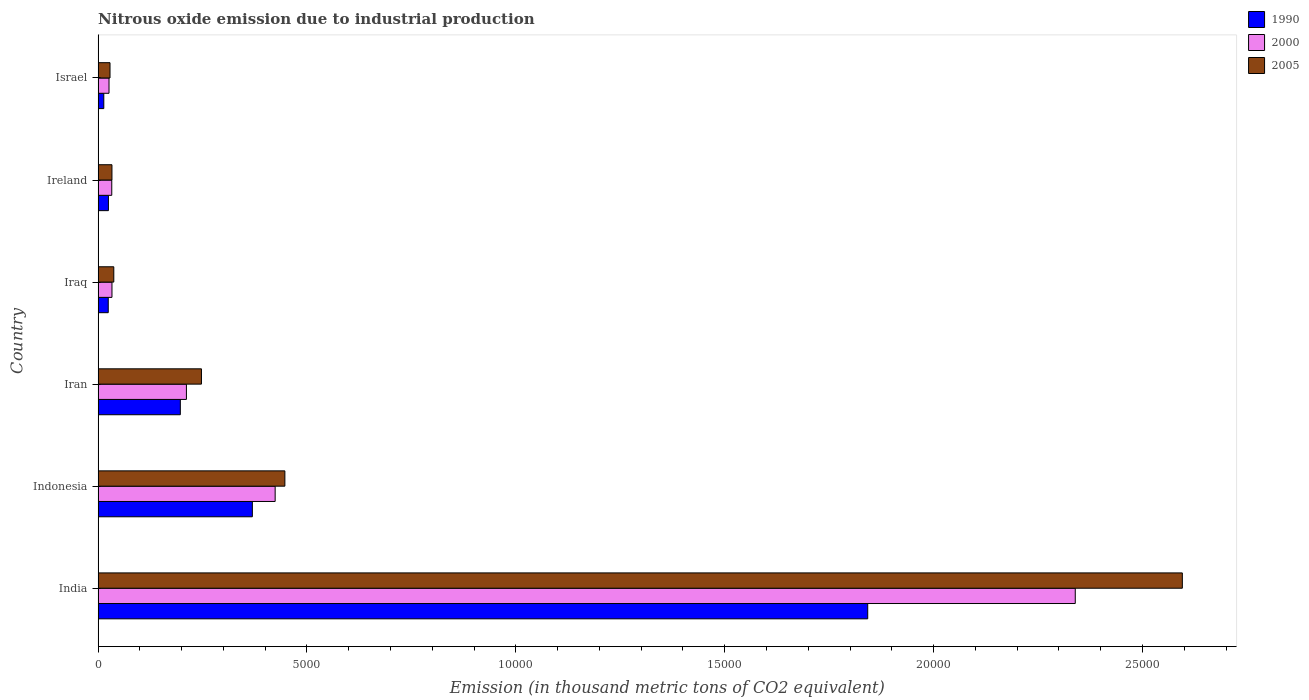How many bars are there on the 6th tick from the top?
Keep it short and to the point. 3. How many bars are there on the 4th tick from the bottom?
Your response must be concise. 3. What is the amount of nitrous oxide emitted in 2005 in Israel?
Your response must be concise. 284.9. Across all countries, what is the maximum amount of nitrous oxide emitted in 2005?
Make the answer very short. 2.60e+04. Across all countries, what is the minimum amount of nitrous oxide emitted in 2005?
Your answer should be very brief. 284.9. In which country was the amount of nitrous oxide emitted in 2000 maximum?
Provide a short and direct response. India. What is the total amount of nitrous oxide emitted in 1990 in the graph?
Make the answer very short. 2.47e+04. What is the difference between the amount of nitrous oxide emitted in 1990 in Indonesia and that in Israel?
Keep it short and to the point. 3556.6. What is the difference between the amount of nitrous oxide emitted in 2005 in Israel and the amount of nitrous oxide emitted in 1990 in Indonesia?
Make the answer very short. -3407.5. What is the average amount of nitrous oxide emitted in 1990 per country?
Offer a terse response. 4118.03. What is the difference between the amount of nitrous oxide emitted in 2005 and amount of nitrous oxide emitted in 1990 in Iraq?
Provide a succinct answer. 133.1. In how many countries, is the amount of nitrous oxide emitted in 2005 greater than 25000 thousand metric tons?
Offer a very short reply. 1. What is the ratio of the amount of nitrous oxide emitted in 2000 in India to that in Iran?
Ensure brevity in your answer.  11.07. What is the difference between the highest and the second highest amount of nitrous oxide emitted in 2000?
Your answer should be very brief. 1.92e+04. What is the difference between the highest and the lowest amount of nitrous oxide emitted in 2005?
Make the answer very short. 2.57e+04. What does the 3rd bar from the top in Ireland represents?
Offer a very short reply. 1990. Is it the case that in every country, the sum of the amount of nitrous oxide emitted in 1990 and amount of nitrous oxide emitted in 2005 is greater than the amount of nitrous oxide emitted in 2000?
Your answer should be very brief. Yes. How many bars are there?
Offer a terse response. 18. How many countries are there in the graph?
Give a very brief answer. 6. Are the values on the major ticks of X-axis written in scientific E-notation?
Your response must be concise. No. Does the graph contain any zero values?
Your answer should be compact. No. Does the graph contain grids?
Offer a terse response. No. Where does the legend appear in the graph?
Your response must be concise. Top right. How many legend labels are there?
Your answer should be very brief. 3. What is the title of the graph?
Your answer should be very brief. Nitrous oxide emission due to industrial production. What is the label or title of the X-axis?
Provide a short and direct response. Emission (in thousand metric tons of CO2 equivalent). What is the Emission (in thousand metric tons of CO2 equivalent) in 1990 in India?
Offer a terse response. 1.84e+04. What is the Emission (in thousand metric tons of CO2 equivalent) of 2000 in India?
Your answer should be very brief. 2.34e+04. What is the Emission (in thousand metric tons of CO2 equivalent) in 2005 in India?
Provide a short and direct response. 2.60e+04. What is the Emission (in thousand metric tons of CO2 equivalent) of 1990 in Indonesia?
Offer a very short reply. 3692.4. What is the Emission (in thousand metric tons of CO2 equivalent) in 2000 in Indonesia?
Your response must be concise. 4237.9. What is the Emission (in thousand metric tons of CO2 equivalent) of 2005 in Indonesia?
Your answer should be compact. 4470.7. What is the Emission (in thousand metric tons of CO2 equivalent) in 1990 in Iran?
Your answer should be very brief. 1968.1. What is the Emission (in thousand metric tons of CO2 equivalent) in 2000 in Iran?
Give a very brief answer. 2113.8. What is the Emission (in thousand metric tons of CO2 equivalent) in 2005 in Iran?
Offer a very short reply. 2473.5. What is the Emission (in thousand metric tons of CO2 equivalent) in 1990 in Iraq?
Keep it short and to the point. 242.4. What is the Emission (in thousand metric tons of CO2 equivalent) of 2000 in Iraq?
Provide a short and direct response. 331.4. What is the Emission (in thousand metric tons of CO2 equivalent) in 2005 in Iraq?
Ensure brevity in your answer.  375.5. What is the Emission (in thousand metric tons of CO2 equivalent) in 1990 in Ireland?
Offer a terse response. 246.7. What is the Emission (in thousand metric tons of CO2 equivalent) of 2000 in Ireland?
Offer a very short reply. 326.6. What is the Emission (in thousand metric tons of CO2 equivalent) of 2005 in Ireland?
Your response must be concise. 331.1. What is the Emission (in thousand metric tons of CO2 equivalent) of 1990 in Israel?
Your answer should be very brief. 135.8. What is the Emission (in thousand metric tons of CO2 equivalent) of 2000 in Israel?
Your answer should be compact. 260.8. What is the Emission (in thousand metric tons of CO2 equivalent) of 2005 in Israel?
Provide a short and direct response. 284.9. Across all countries, what is the maximum Emission (in thousand metric tons of CO2 equivalent) in 1990?
Provide a succinct answer. 1.84e+04. Across all countries, what is the maximum Emission (in thousand metric tons of CO2 equivalent) in 2000?
Offer a terse response. 2.34e+04. Across all countries, what is the maximum Emission (in thousand metric tons of CO2 equivalent) in 2005?
Ensure brevity in your answer.  2.60e+04. Across all countries, what is the minimum Emission (in thousand metric tons of CO2 equivalent) in 1990?
Your answer should be very brief. 135.8. Across all countries, what is the minimum Emission (in thousand metric tons of CO2 equivalent) of 2000?
Provide a succinct answer. 260.8. Across all countries, what is the minimum Emission (in thousand metric tons of CO2 equivalent) in 2005?
Ensure brevity in your answer.  284.9. What is the total Emission (in thousand metric tons of CO2 equivalent) of 1990 in the graph?
Make the answer very short. 2.47e+04. What is the total Emission (in thousand metric tons of CO2 equivalent) of 2000 in the graph?
Provide a short and direct response. 3.07e+04. What is the total Emission (in thousand metric tons of CO2 equivalent) of 2005 in the graph?
Keep it short and to the point. 3.39e+04. What is the difference between the Emission (in thousand metric tons of CO2 equivalent) of 1990 in India and that in Indonesia?
Your answer should be very brief. 1.47e+04. What is the difference between the Emission (in thousand metric tons of CO2 equivalent) of 2000 in India and that in Indonesia?
Ensure brevity in your answer.  1.92e+04. What is the difference between the Emission (in thousand metric tons of CO2 equivalent) of 2005 in India and that in Indonesia?
Offer a terse response. 2.15e+04. What is the difference between the Emission (in thousand metric tons of CO2 equivalent) of 1990 in India and that in Iran?
Offer a terse response. 1.65e+04. What is the difference between the Emission (in thousand metric tons of CO2 equivalent) in 2000 in India and that in Iran?
Make the answer very short. 2.13e+04. What is the difference between the Emission (in thousand metric tons of CO2 equivalent) of 2005 in India and that in Iran?
Make the answer very short. 2.35e+04. What is the difference between the Emission (in thousand metric tons of CO2 equivalent) of 1990 in India and that in Iraq?
Offer a very short reply. 1.82e+04. What is the difference between the Emission (in thousand metric tons of CO2 equivalent) of 2000 in India and that in Iraq?
Your answer should be compact. 2.31e+04. What is the difference between the Emission (in thousand metric tons of CO2 equivalent) of 2005 in India and that in Iraq?
Provide a succinct answer. 2.56e+04. What is the difference between the Emission (in thousand metric tons of CO2 equivalent) in 1990 in India and that in Ireland?
Keep it short and to the point. 1.82e+04. What is the difference between the Emission (in thousand metric tons of CO2 equivalent) of 2000 in India and that in Ireland?
Keep it short and to the point. 2.31e+04. What is the difference between the Emission (in thousand metric tons of CO2 equivalent) in 2005 in India and that in Ireland?
Your answer should be compact. 2.56e+04. What is the difference between the Emission (in thousand metric tons of CO2 equivalent) of 1990 in India and that in Israel?
Make the answer very short. 1.83e+04. What is the difference between the Emission (in thousand metric tons of CO2 equivalent) in 2000 in India and that in Israel?
Provide a short and direct response. 2.31e+04. What is the difference between the Emission (in thousand metric tons of CO2 equivalent) in 2005 in India and that in Israel?
Your answer should be very brief. 2.57e+04. What is the difference between the Emission (in thousand metric tons of CO2 equivalent) in 1990 in Indonesia and that in Iran?
Your answer should be compact. 1724.3. What is the difference between the Emission (in thousand metric tons of CO2 equivalent) in 2000 in Indonesia and that in Iran?
Give a very brief answer. 2124.1. What is the difference between the Emission (in thousand metric tons of CO2 equivalent) in 2005 in Indonesia and that in Iran?
Provide a succinct answer. 1997.2. What is the difference between the Emission (in thousand metric tons of CO2 equivalent) in 1990 in Indonesia and that in Iraq?
Offer a terse response. 3450. What is the difference between the Emission (in thousand metric tons of CO2 equivalent) in 2000 in Indonesia and that in Iraq?
Your response must be concise. 3906.5. What is the difference between the Emission (in thousand metric tons of CO2 equivalent) of 2005 in Indonesia and that in Iraq?
Your answer should be very brief. 4095.2. What is the difference between the Emission (in thousand metric tons of CO2 equivalent) of 1990 in Indonesia and that in Ireland?
Your response must be concise. 3445.7. What is the difference between the Emission (in thousand metric tons of CO2 equivalent) in 2000 in Indonesia and that in Ireland?
Offer a terse response. 3911.3. What is the difference between the Emission (in thousand metric tons of CO2 equivalent) in 2005 in Indonesia and that in Ireland?
Your answer should be compact. 4139.6. What is the difference between the Emission (in thousand metric tons of CO2 equivalent) in 1990 in Indonesia and that in Israel?
Your answer should be very brief. 3556.6. What is the difference between the Emission (in thousand metric tons of CO2 equivalent) of 2000 in Indonesia and that in Israel?
Your answer should be compact. 3977.1. What is the difference between the Emission (in thousand metric tons of CO2 equivalent) in 2005 in Indonesia and that in Israel?
Keep it short and to the point. 4185.8. What is the difference between the Emission (in thousand metric tons of CO2 equivalent) in 1990 in Iran and that in Iraq?
Offer a very short reply. 1725.7. What is the difference between the Emission (in thousand metric tons of CO2 equivalent) in 2000 in Iran and that in Iraq?
Offer a very short reply. 1782.4. What is the difference between the Emission (in thousand metric tons of CO2 equivalent) in 2005 in Iran and that in Iraq?
Provide a succinct answer. 2098. What is the difference between the Emission (in thousand metric tons of CO2 equivalent) in 1990 in Iran and that in Ireland?
Provide a succinct answer. 1721.4. What is the difference between the Emission (in thousand metric tons of CO2 equivalent) in 2000 in Iran and that in Ireland?
Provide a short and direct response. 1787.2. What is the difference between the Emission (in thousand metric tons of CO2 equivalent) in 2005 in Iran and that in Ireland?
Ensure brevity in your answer.  2142.4. What is the difference between the Emission (in thousand metric tons of CO2 equivalent) in 1990 in Iran and that in Israel?
Provide a short and direct response. 1832.3. What is the difference between the Emission (in thousand metric tons of CO2 equivalent) of 2000 in Iran and that in Israel?
Offer a very short reply. 1853. What is the difference between the Emission (in thousand metric tons of CO2 equivalent) in 2005 in Iran and that in Israel?
Your response must be concise. 2188.6. What is the difference between the Emission (in thousand metric tons of CO2 equivalent) of 1990 in Iraq and that in Ireland?
Ensure brevity in your answer.  -4.3. What is the difference between the Emission (in thousand metric tons of CO2 equivalent) of 2005 in Iraq and that in Ireland?
Your answer should be compact. 44.4. What is the difference between the Emission (in thousand metric tons of CO2 equivalent) in 1990 in Iraq and that in Israel?
Your answer should be very brief. 106.6. What is the difference between the Emission (in thousand metric tons of CO2 equivalent) of 2000 in Iraq and that in Israel?
Your answer should be very brief. 70.6. What is the difference between the Emission (in thousand metric tons of CO2 equivalent) of 2005 in Iraq and that in Israel?
Make the answer very short. 90.6. What is the difference between the Emission (in thousand metric tons of CO2 equivalent) in 1990 in Ireland and that in Israel?
Make the answer very short. 110.9. What is the difference between the Emission (in thousand metric tons of CO2 equivalent) of 2000 in Ireland and that in Israel?
Offer a terse response. 65.8. What is the difference between the Emission (in thousand metric tons of CO2 equivalent) in 2005 in Ireland and that in Israel?
Offer a terse response. 46.2. What is the difference between the Emission (in thousand metric tons of CO2 equivalent) in 1990 in India and the Emission (in thousand metric tons of CO2 equivalent) in 2000 in Indonesia?
Give a very brief answer. 1.42e+04. What is the difference between the Emission (in thousand metric tons of CO2 equivalent) of 1990 in India and the Emission (in thousand metric tons of CO2 equivalent) of 2005 in Indonesia?
Provide a succinct answer. 1.40e+04. What is the difference between the Emission (in thousand metric tons of CO2 equivalent) of 2000 in India and the Emission (in thousand metric tons of CO2 equivalent) of 2005 in Indonesia?
Your answer should be very brief. 1.89e+04. What is the difference between the Emission (in thousand metric tons of CO2 equivalent) in 1990 in India and the Emission (in thousand metric tons of CO2 equivalent) in 2000 in Iran?
Provide a succinct answer. 1.63e+04. What is the difference between the Emission (in thousand metric tons of CO2 equivalent) of 1990 in India and the Emission (in thousand metric tons of CO2 equivalent) of 2005 in Iran?
Keep it short and to the point. 1.59e+04. What is the difference between the Emission (in thousand metric tons of CO2 equivalent) of 2000 in India and the Emission (in thousand metric tons of CO2 equivalent) of 2005 in Iran?
Ensure brevity in your answer.  2.09e+04. What is the difference between the Emission (in thousand metric tons of CO2 equivalent) in 1990 in India and the Emission (in thousand metric tons of CO2 equivalent) in 2000 in Iraq?
Your answer should be compact. 1.81e+04. What is the difference between the Emission (in thousand metric tons of CO2 equivalent) of 1990 in India and the Emission (in thousand metric tons of CO2 equivalent) of 2005 in Iraq?
Provide a short and direct response. 1.80e+04. What is the difference between the Emission (in thousand metric tons of CO2 equivalent) in 2000 in India and the Emission (in thousand metric tons of CO2 equivalent) in 2005 in Iraq?
Provide a succinct answer. 2.30e+04. What is the difference between the Emission (in thousand metric tons of CO2 equivalent) of 1990 in India and the Emission (in thousand metric tons of CO2 equivalent) of 2000 in Ireland?
Give a very brief answer. 1.81e+04. What is the difference between the Emission (in thousand metric tons of CO2 equivalent) in 1990 in India and the Emission (in thousand metric tons of CO2 equivalent) in 2005 in Ireland?
Make the answer very short. 1.81e+04. What is the difference between the Emission (in thousand metric tons of CO2 equivalent) in 2000 in India and the Emission (in thousand metric tons of CO2 equivalent) in 2005 in Ireland?
Provide a succinct answer. 2.31e+04. What is the difference between the Emission (in thousand metric tons of CO2 equivalent) in 1990 in India and the Emission (in thousand metric tons of CO2 equivalent) in 2000 in Israel?
Give a very brief answer. 1.82e+04. What is the difference between the Emission (in thousand metric tons of CO2 equivalent) in 1990 in India and the Emission (in thousand metric tons of CO2 equivalent) in 2005 in Israel?
Keep it short and to the point. 1.81e+04. What is the difference between the Emission (in thousand metric tons of CO2 equivalent) of 2000 in India and the Emission (in thousand metric tons of CO2 equivalent) of 2005 in Israel?
Your answer should be compact. 2.31e+04. What is the difference between the Emission (in thousand metric tons of CO2 equivalent) in 1990 in Indonesia and the Emission (in thousand metric tons of CO2 equivalent) in 2000 in Iran?
Your answer should be very brief. 1578.6. What is the difference between the Emission (in thousand metric tons of CO2 equivalent) in 1990 in Indonesia and the Emission (in thousand metric tons of CO2 equivalent) in 2005 in Iran?
Offer a very short reply. 1218.9. What is the difference between the Emission (in thousand metric tons of CO2 equivalent) of 2000 in Indonesia and the Emission (in thousand metric tons of CO2 equivalent) of 2005 in Iran?
Keep it short and to the point. 1764.4. What is the difference between the Emission (in thousand metric tons of CO2 equivalent) of 1990 in Indonesia and the Emission (in thousand metric tons of CO2 equivalent) of 2000 in Iraq?
Offer a terse response. 3361. What is the difference between the Emission (in thousand metric tons of CO2 equivalent) of 1990 in Indonesia and the Emission (in thousand metric tons of CO2 equivalent) of 2005 in Iraq?
Make the answer very short. 3316.9. What is the difference between the Emission (in thousand metric tons of CO2 equivalent) in 2000 in Indonesia and the Emission (in thousand metric tons of CO2 equivalent) in 2005 in Iraq?
Your answer should be very brief. 3862.4. What is the difference between the Emission (in thousand metric tons of CO2 equivalent) in 1990 in Indonesia and the Emission (in thousand metric tons of CO2 equivalent) in 2000 in Ireland?
Keep it short and to the point. 3365.8. What is the difference between the Emission (in thousand metric tons of CO2 equivalent) of 1990 in Indonesia and the Emission (in thousand metric tons of CO2 equivalent) of 2005 in Ireland?
Offer a terse response. 3361.3. What is the difference between the Emission (in thousand metric tons of CO2 equivalent) of 2000 in Indonesia and the Emission (in thousand metric tons of CO2 equivalent) of 2005 in Ireland?
Your answer should be compact. 3906.8. What is the difference between the Emission (in thousand metric tons of CO2 equivalent) in 1990 in Indonesia and the Emission (in thousand metric tons of CO2 equivalent) in 2000 in Israel?
Give a very brief answer. 3431.6. What is the difference between the Emission (in thousand metric tons of CO2 equivalent) in 1990 in Indonesia and the Emission (in thousand metric tons of CO2 equivalent) in 2005 in Israel?
Offer a very short reply. 3407.5. What is the difference between the Emission (in thousand metric tons of CO2 equivalent) of 2000 in Indonesia and the Emission (in thousand metric tons of CO2 equivalent) of 2005 in Israel?
Your answer should be very brief. 3953. What is the difference between the Emission (in thousand metric tons of CO2 equivalent) of 1990 in Iran and the Emission (in thousand metric tons of CO2 equivalent) of 2000 in Iraq?
Your answer should be very brief. 1636.7. What is the difference between the Emission (in thousand metric tons of CO2 equivalent) in 1990 in Iran and the Emission (in thousand metric tons of CO2 equivalent) in 2005 in Iraq?
Provide a succinct answer. 1592.6. What is the difference between the Emission (in thousand metric tons of CO2 equivalent) in 2000 in Iran and the Emission (in thousand metric tons of CO2 equivalent) in 2005 in Iraq?
Make the answer very short. 1738.3. What is the difference between the Emission (in thousand metric tons of CO2 equivalent) in 1990 in Iran and the Emission (in thousand metric tons of CO2 equivalent) in 2000 in Ireland?
Your answer should be very brief. 1641.5. What is the difference between the Emission (in thousand metric tons of CO2 equivalent) of 1990 in Iran and the Emission (in thousand metric tons of CO2 equivalent) of 2005 in Ireland?
Your answer should be very brief. 1637. What is the difference between the Emission (in thousand metric tons of CO2 equivalent) in 2000 in Iran and the Emission (in thousand metric tons of CO2 equivalent) in 2005 in Ireland?
Ensure brevity in your answer.  1782.7. What is the difference between the Emission (in thousand metric tons of CO2 equivalent) in 1990 in Iran and the Emission (in thousand metric tons of CO2 equivalent) in 2000 in Israel?
Make the answer very short. 1707.3. What is the difference between the Emission (in thousand metric tons of CO2 equivalent) in 1990 in Iran and the Emission (in thousand metric tons of CO2 equivalent) in 2005 in Israel?
Provide a short and direct response. 1683.2. What is the difference between the Emission (in thousand metric tons of CO2 equivalent) in 2000 in Iran and the Emission (in thousand metric tons of CO2 equivalent) in 2005 in Israel?
Keep it short and to the point. 1828.9. What is the difference between the Emission (in thousand metric tons of CO2 equivalent) of 1990 in Iraq and the Emission (in thousand metric tons of CO2 equivalent) of 2000 in Ireland?
Keep it short and to the point. -84.2. What is the difference between the Emission (in thousand metric tons of CO2 equivalent) of 1990 in Iraq and the Emission (in thousand metric tons of CO2 equivalent) of 2005 in Ireland?
Provide a short and direct response. -88.7. What is the difference between the Emission (in thousand metric tons of CO2 equivalent) in 1990 in Iraq and the Emission (in thousand metric tons of CO2 equivalent) in 2000 in Israel?
Your answer should be very brief. -18.4. What is the difference between the Emission (in thousand metric tons of CO2 equivalent) in 1990 in Iraq and the Emission (in thousand metric tons of CO2 equivalent) in 2005 in Israel?
Your answer should be compact. -42.5. What is the difference between the Emission (in thousand metric tons of CO2 equivalent) in 2000 in Iraq and the Emission (in thousand metric tons of CO2 equivalent) in 2005 in Israel?
Make the answer very short. 46.5. What is the difference between the Emission (in thousand metric tons of CO2 equivalent) in 1990 in Ireland and the Emission (in thousand metric tons of CO2 equivalent) in 2000 in Israel?
Offer a terse response. -14.1. What is the difference between the Emission (in thousand metric tons of CO2 equivalent) of 1990 in Ireland and the Emission (in thousand metric tons of CO2 equivalent) of 2005 in Israel?
Give a very brief answer. -38.2. What is the difference between the Emission (in thousand metric tons of CO2 equivalent) in 2000 in Ireland and the Emission (in thousand metric tons of CO2 equivalent) in 2005 in Israel?
Make the answer very short. 41.7. What is the average Emission (in thousand metric tons of CO2 equivalent) in 1990 per country?
Give a very brief answer. 4118.03. What is the average Emission (in thousand metric tons of CO2 equivalent) in 2000 per country?
Offer a very short reply. 5110.3. What is the average Emission (in thousand metric tons of CO2 equivalent) of 2005 per country?
Ensure brevity in your answer.  5648.35. What is the difference between the Emission (in thousand metric tons of CO2 equivalent) in 1990 and Emission (in thousand metric tons of CO2 equivalent) in 2000 in India?
Provide a succinct answer. -4968.5. What is the difference between the Emission (in thousand metric tons of CO2 equivalent) in 1990 and Emission (in thousand metric tons of CO2 equivalent) in 2005 in India?
Ensure brevity in your answer.  -7531.6. What is the difference between the Emission (in thousand metric tons of CO2 equivalent) of 2000 and Emission (in thousand metric tons of CO2 equivalent) of 2005 in India?
Your answer should be compact. -2563.1. What is the difference between the Emission (in thousand metric tons of CO2 equivalent) in 1990 and Emission (in thousand metric tons of CO2 equivalent) in 2000 in Indonesia?
Keep it short and to the point. -545.5. What is the difference between the Emission (in thousand metric tons of CO2 equivalent) of 1990 and Emission (in thousand metric tons of CO2 equivalent) of 2005 in Indonesia?
Offer a very short reply. -778.3. What is the difference between the Emission (in thousand metric tons of CO2 equivalent) of 2000 and Emission (in thousand metric tons of CO2 equivalent) of 2005 in Indonesia?
Ensure brevity in your answer.  -232.8. What is the difference between the Emission (in thousand metric tons of CO2 equivalent) in 1990 and Emission (in thousand metric tons of CO2 equivalent) in 2000 in Iran?
Provide a succinct answer. -145.7. What is the difference between the Emission (in thousand metric tons of CO2 equivalent) in 1990 and Emission (in thousand metric tons of CO2 equivalent) in 2005 in Iran?
Make the answer very short. -505.4. What is the difference between the Emission (in thousand metric tons of CO2 equivalent) in 2000 and Emission (in thousand metric tons of CO2 equivalent) in 2005 in Iran?
Your answer should be compact. -359.7. What is the difference between the Emission (in thousand metric tons of CO2 equivalent) in 1990 and Emission (in thousand metric tons of CO2 equivalent) in 2000 in Iraq?
Offer a very short reply. -89. What is the difference between the Emission (in thousand metric tons of CO2 equivalent) in 1990 and Emission (in thousand metric tons of CO2 equivalent) in 2005 in Iraq?
Provide a short and direct response. -133.1. What is the difference between the Emission (in thousand metric tons of CO2 equivalent) of 2000 and Emission (in thousand metric tons of CO2 equivalent) of 2005 in Iraq?
Provide a short and direct response. -44.1. What is the difference between the Emission (in thousand metric tons of CO2 equivalent) of 1990 and Emission (in thousand metric tons of CO2 equivalent) of 2000 in Ireland?
Make the answer very short. -79.9. What is the difference between the Emission (in thousand metric tons of CO2 equivalent) of 1990 and Emission (in thousand metric tons of CO2 equivalent) of 2005 in Ireland?
Your answer should be compact. -84.4. What is the difference between the Emission (in thousand metric tons of CO2 equivalent) in 1990 and Emission (in thousand metric tons of CO2 equivalent) in 2000 in Israel?
Your response must be concise. -125. What is the difference between the Emission (in thousand metric tons of CO2 equivalent) of 1990 and Emission (in thousand metric tons of CO2 equivalent) of 2005 in Israel?
Keep it short and to the point. -149.1. What is the difference between the Emission (in thousand metric tons of CO2 equivalent) of 2000 and Emission (in thousand metric tons of CO2 equivalent) of 2005 in Israel?
Provide a short and direct response. -24.1. What is the ratio of the Emission (in thousand metric tons of CO2 equivalent) in 1990 in India to that in Indonesia?
Your answer should be compact. 4.99. What is the ratio of the Emission (in thousand metric tons of CO2 equivalent) in 2000 in India to that in Indonesia?
Ensure brevity in your answer.  5.52. What is the ratio of the Emission (in thousand metric tons of CO2 equivalent) in 2005 in India to that in Indonesia?
Your response must be concise. 5.81. What is the ratio of the Emission (in thousand metric tons of CO2 equivalent) of 1990 in India to that in Iran?
Offer a very short reply. 9.36. What is the ratio of the Emission (in thousand metric tons of CO2 equivalent) in 2000 in India to that in Iran?
Offer a very short reply. 11.07. What is the ratio of the Emission (in thousand metric tons of CO2 equivalent) of 2005 in India to that in Iran?
Make the answer very short. 10.49. What is the ratio of the Emission (in thousand metric tons of CO2 equivalent) of 1990 in India to that in Iraq?
Give a very brief answer. 76. What is the ratio of the Emission (in thousand metric tons of CO2 equivalent) in 2000 in India to that in Iraq?
Your response must be concise. 70.58. What is the ratio of the Emission (in thousand metric tons of CO2 equivalent) of 2005 in India to that in Iraq?
Provide a succinct answer. 69.12. What is the ratio of the Emission (in thousand metric tons of CO2 equivalent) in 1990 in India to that in Ireland?
Give a very brief answer. 74.68. What is the ratio of the Emission (in thousand metric tons of CO2 equivalent) of 2000 in India to that in Ireland?
Your response must be concise. 71.62. What is the ratio of the Emission (in thousand metric tons of CO2 equivalent) in 2005 in India to that in Ireland?
Ensure brevity in your answer.  78.39. What is the ratio of the Emission (in thousand metric tons of CO2 equivalent) of 1990 in India to that in Israel?
Your response must be concise. 135.66. What is the ratio of the Emission (in thousand metric tons of CO2 equivalent) in 2000 in India to that in Israel?
Ensure brevity in your answer.  89.69. What is the ratio of the Emission (in thousand metric tons of CO2 equivalent) in 2005 in India to that in Israel?
Provide a succinct answer. 91.1. What is the ratio of the Emission (in thousand metric tons of CO2 equivalent) in 1990 in Indonesia to that in Iran?
Provide a short and direct response. 1.88. What is the ratio of the Emission (in thousand metric tons of CO2 equivalent) in 2000 in Indonesia to that in Iran?
Offer a terse response. 2. What is the ratio of the Emission (in thousand metric tons of CO2 equivalent) of 2005 in Indonesia to that in Iran?
Offer a very short reply. 1.81. What is the ratio of the Emission (in thousand metric tons of CO2 equivalent) in 1990 in Indonesia to that in Iraq?
Provide a short and direct response. 15.23. What is the ratio of the Emission (in thousand metric tons of CO2 equivalent) of 2000 in Indonesia to that in Iraq?
Provide a short and direct response. 12.79. What is the ratio of the Emission (in thousand metric tons of CO2 equivalent) in 2005 in Indonesia to that in Iraq?
Your answer should be compact. 11.91. What is the ratio of the Emission (in thousand metric tons of CO2 equivalent) in 1990 in Indonesia to that in Ireland?
Provide a short and direct response. 14.97. What is the ratio of the Emission (in thousand metric tons of CO2 equivalent) of 2000 in Indonesia to that in Ireland?
Offer a very short reply. 12.98. What is the ratio of the Emission (in thousand metric tons of CO2 equivalent) in 2005 in Indonesia to that in Ireland?
Give a very brief answer. 13.5. What is the ratio of the Emission (in thousand metric tons of CO2 equivalent) in 1990 in Indonesia to that in Israel?
Ensure brevity in your answer.  27.19. What is the ratio of the Emission (in thousand metric tons of CO2 equivalent) in 2000 in Indonesia to that in Israel?
Your answer should be compact. 16.25. What is the ratio of the Emission (in thousand metric tons of CO2 equivalent) of 2005 in Indonesia to that in Israel?
Offer a terse response. 15.69. What is the ratio of the Emission (in thousand metric tons of CO2 equivalent) in 1990 in Iran to that in Iraq?
Keep it short and to the point. 8.12. What is the ratio of the Emission (in thousand metric tons of CO2 equivalent) of 2000 in Iran to that in Iraq?
Give a very brief answer. 6.38. What is the ratio of the Emission (in thousand metric tons of CO2 equivalent) of 2005 in Iran to that in Iraq?
Your answer should be very brief. 6.59. What is the ratio of the Emission (in thousand metric tons of CO2 equivalent) of 1990 in Iran to that in Ireland?
Make the answer very short. 7.98. What is the ratio of the Emission (in thousand metric tons of CO2 equivalent) in 2000 in Iran to that in Ireland?
Ensure brevity in your answer.  6.47. What is the ratio of the Emission (in thousand metric tons of CO2 equivalent) in 2005 in Iran to that in Ireland?
Provide a succinct answer. 7.47. What is the ratio of the Emission (in thousand metric tons of CO2 equivalent) of 1990 in Iran to that in Israel?
Give a very brief answer. 14.49. What is the ratio of the Emission (in thousand metric tons of CO2 equivalent) in 2000 in Iran to that in Israel?
Provide a succinct answer. 8.11. What is the ratio of the Emission (in thousand metric tons of CO2 equivalent) in 2005 in Iran to that in Israel?
Your answer should be very brief. 8.68. What is the ratio of the Emission (in thousand metric tons of CO2 equivalent) of 1990 in Iraq to that in Ireland?
Offer a terse response. 0.98. What is the ratio of the Emission (in thousand metric tons of CO2 equivalent) in 2000 in Iraq to that in Ireland?
Your response must be concise. 1.01. What is the ratio of the Emission (in thousand metric tons of CO2 equivalent) in 2005 in Iraq to that in Ireland?
Provide a succinct answer. 1.13. What is the ratio of the Emission (in thousand metric tons of CO2 equivalent) in 1990 in Iraq to that in Israel?
Ensure brevity in your answer.  1.78. What is the ratio of the Emission (in thousand metric tons of CO2 equivalent) in 2000 in Iraq to that in Israel?
Make the answer very short. 1.27. What is the ratio of the Emission (in thousand metric tons of CO2 equivalent) of 2005 in Iraq to that in Israel?
Offer a very short reply. 1.32. What is the ratio of the Emission (in thousand metric tons of CO2 equivalent) of 1990 in Ireland to that in Israel?
Make the answer very short. 1.82. What is the ratio of the Emission (in thousand metric tons of CO2 equivalent) of 2000 in Ireland to that in Israel?
Make the answer very short. 1.25. What is the ratio of the Emission (in thousand metric tons of CO2 equivalent) of 2005 in Ireland to that in Israel?
Your answer should be compact. 1.16. What is the difference between the highest and the second highest Emission (in thousand metric tons of CO2 equivalent) of 1990?
Your response must be concise. 1.47e+04. What is the difference between the highest and the second highest Emission (in thousand metric tons of CO2 equivalent) of 2000?
Make the answer very short. 1.92e+04. What is the difference between the highest and the second highest Emission (in thousand metric tons of CO2 equivalent) of 2005?
Your answer should be compact. 2.15e+04. What is the difference between the highest and the lowest Emission (in thousand metric tons of CO2 equivalent) of 1990?
Your response must be concise. 1.83e+04. What is the difference between the highest and the lowest Emission (in thousand metric tons of CO2 equivalent) in 2000?
Your answer should be very brief. 2.31e+04. What is the difference between the highest and the lowest Emission (in thousand metric tons of CO2 equivalent) of 2005?
Offer a very short reply. 2.57e+04. 